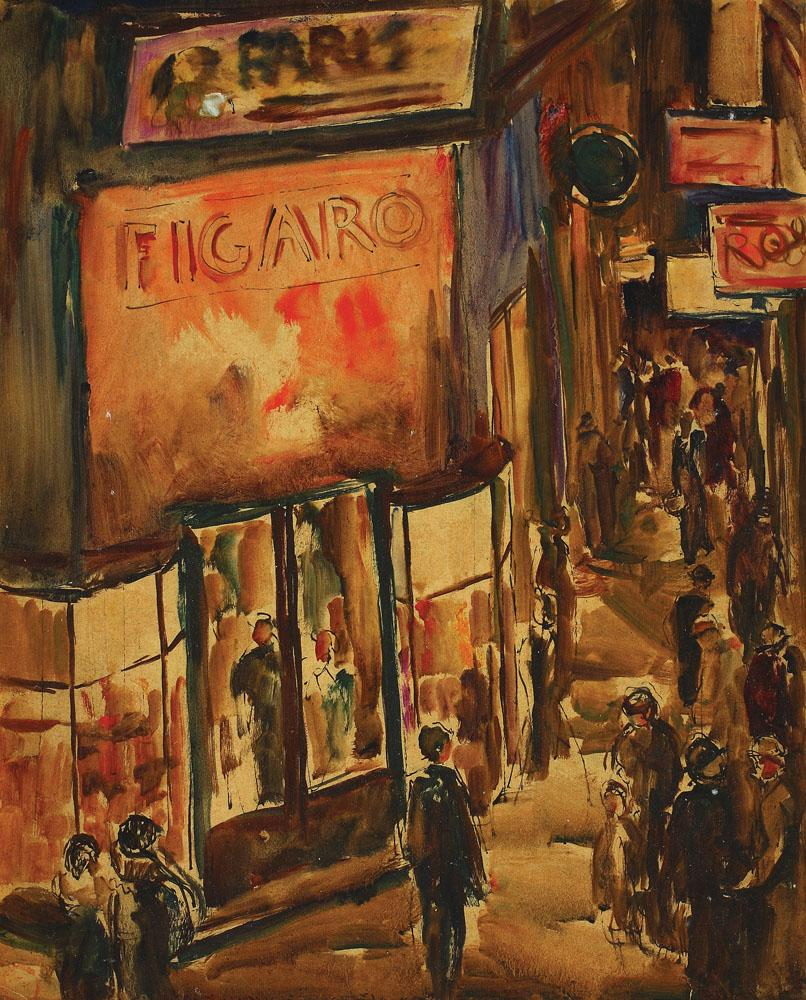Describe the potential history of the building with the FIGARO sign. The building with the FIGARO sign has stood as a silent witness to countless stories over the decades. Originally constructed as a café in the mid-1800s, it quickly became a hub for intellectuals, artists, and writers. By the early 1900s, it had transformed into a high-end fashion boutique, with its large windows showcasing the latest Parisian trends. The FIGARO sign, added in the 1920s, became an iconic symbol of the neighborhood's blend of tradition and modernity. Throughout wars and peacetime, the building has remained a steadfast monument to the ever-evolving cultural tapestry of the city. Imagine the painter's thought process while creating this piece. Standing at his easel, the painter immersed himself in the bustling energy of the street. He chose a palette of warm, inviting colors, hoping to convey the warmth and vibrancy of the evening scene. With each brushstroke, he aimed to capture the fleeting moments of daily life—the hurried step of a passerby, the soft glow of the storefront, the indistinct chatter of the crowd. His goal was not just to depict a scene, but to evoke the feeling of being there, in that very moment, feeling the city's pulse and rhythm. As he painted, he reflected on the layers of history and personal stories intertwined within the walls of the FIGARO building, aiming to immortalize a snapshot of urban life through the fluidity and freedom of the impressionist style. Imagine if this scene was part of a futuristic setting. Describe it creatively. In a not-so-distant future, the FIGARO building had become a beacon of neon lights in the midst of a cybernetic metropolis. The large, holographic sign flickered ever so slightly, advertising the latest in virtual fashion trends. Mannequins in the window now donned clothes made from smart fabrics, which changed color based on the wearer's mood. The street below buzzed with a diverse mix of humans and androids, all going about their day in a hustle reminiscent of the past yet markedly advanced. The air hummed with the soft whir of drones delivering packages and the occasional burst of laughter from children playing with augmented reality games. Yet, despite the technological advancements, the warm hues of nostalgia and the essence of a bustling street life remained ever-present, bridging the gap between the past and the future. 